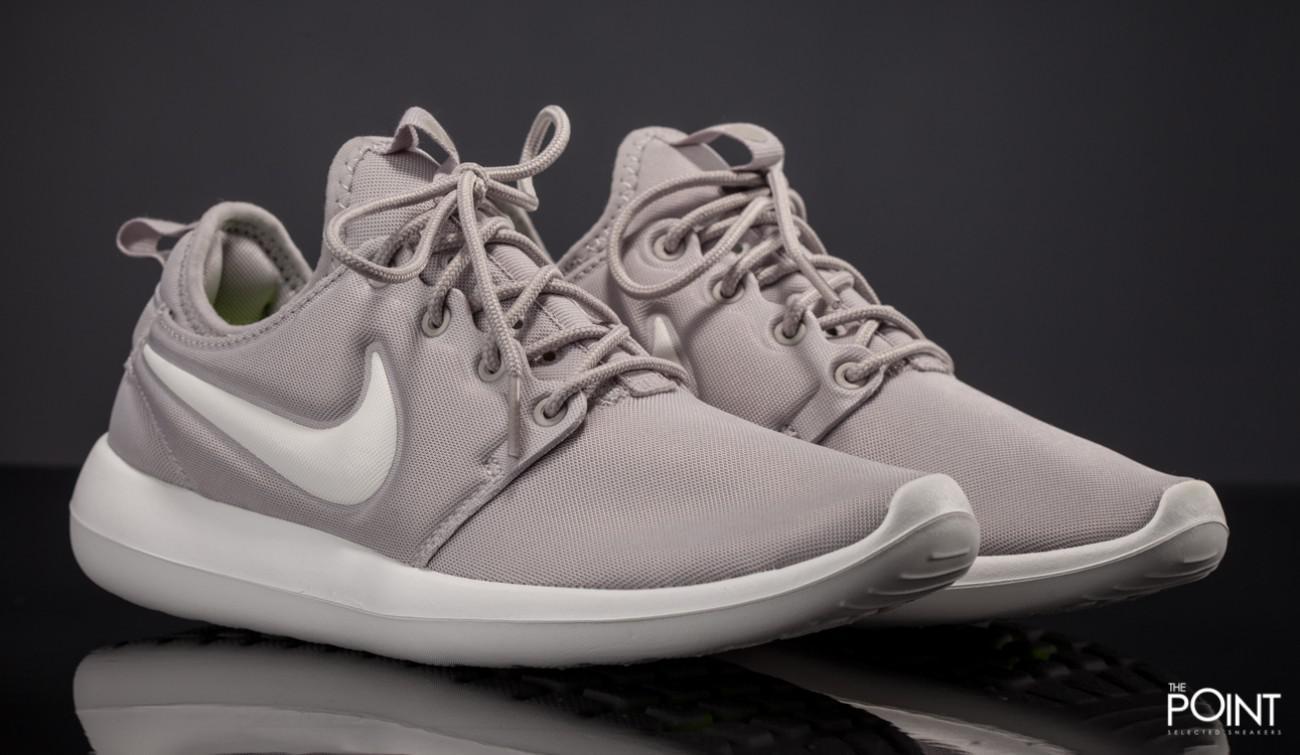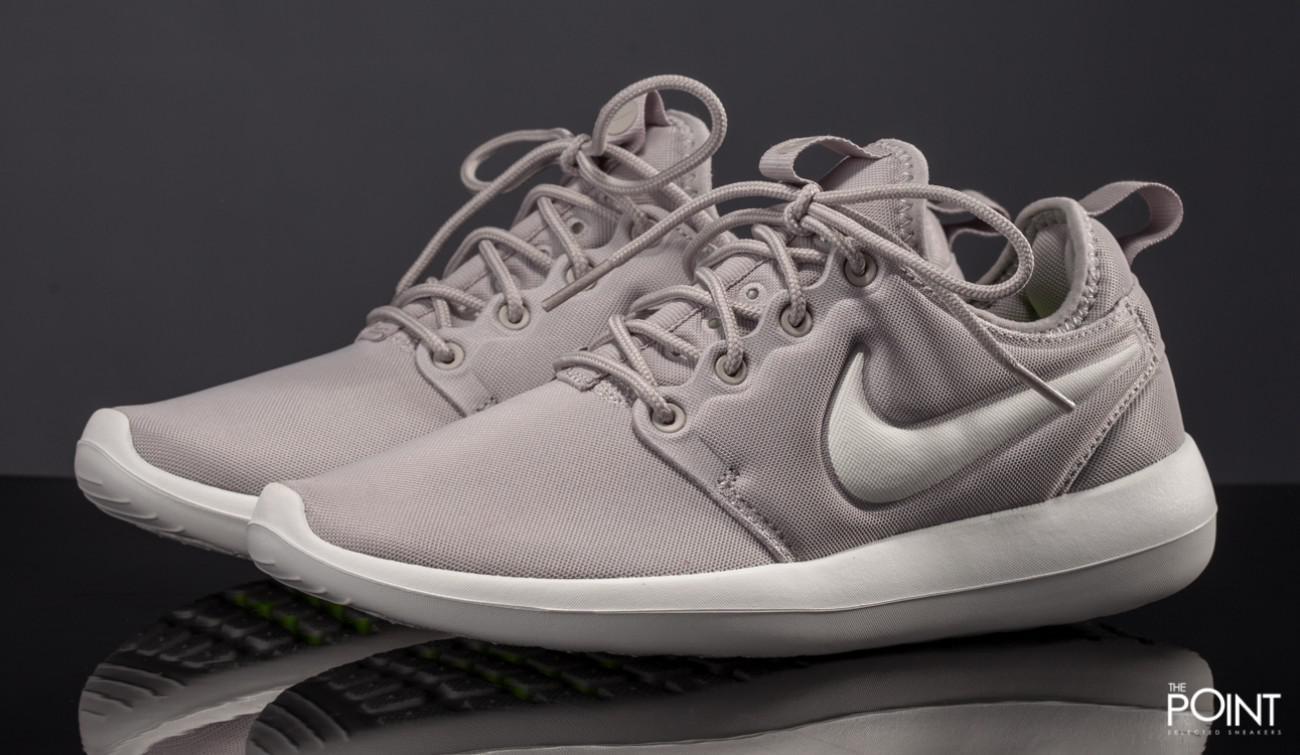The first image is the image on the left, the second image is the image on the right. For the images shown, is this caption "Both images show a pair of grey sneakers that aren't currently worn by anyone." true? Answer yes or no. Yes. The first image is the image on the left, the second image is the image on the right. For the images displayed, is the sentence "Each image contains one unworn, matched pair of sneakers posed soles-downward, and the sneakers in the left and right images face inward toward each other." factually correct? Answer yes or no. Yes. 